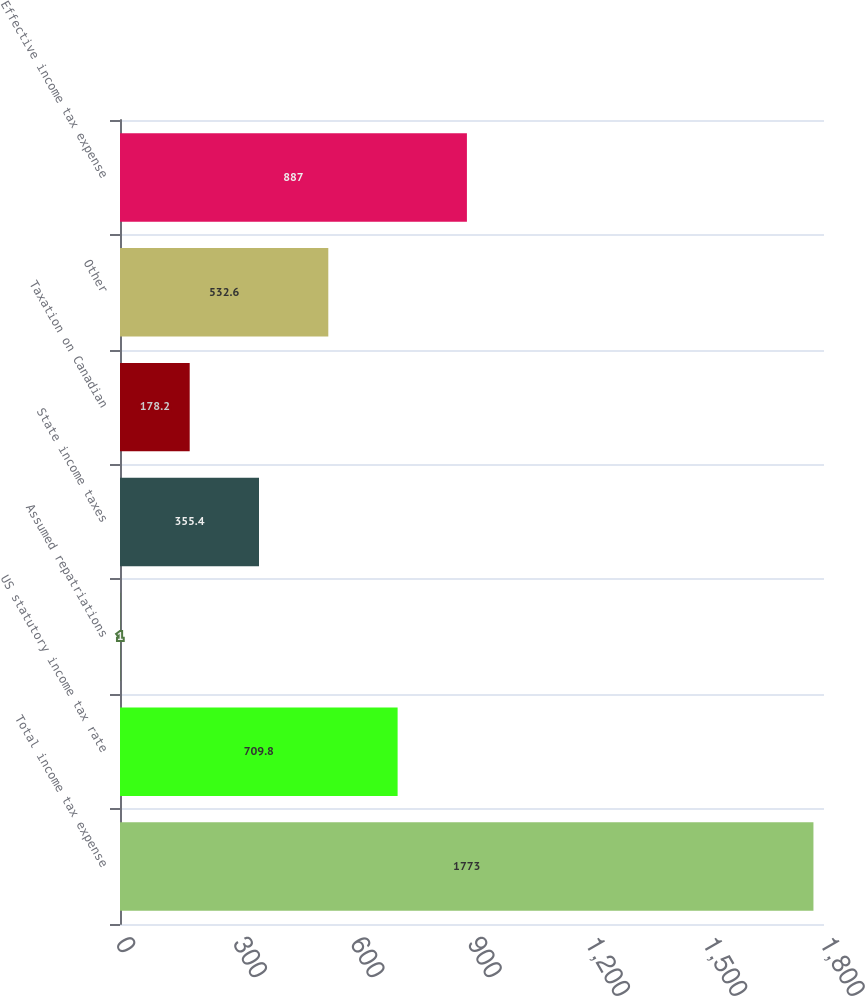Convert chart. <chart><loc_0><loc_0><loc_500><loc_500><bar_chart><fcel>Total income tax expense<fcel>US statutory income tax rate<fcel>Assumed repatriations<fcel>State income taxes<fcel>Taxation on Canadian<fcel>Other<fcel>Effective income tax expense<nl><fcel>1773<fcel>709.8<fcel>1<fcel>355.4<fcel>178.2<fcel>532.6<fcel>887<nl></chart> 